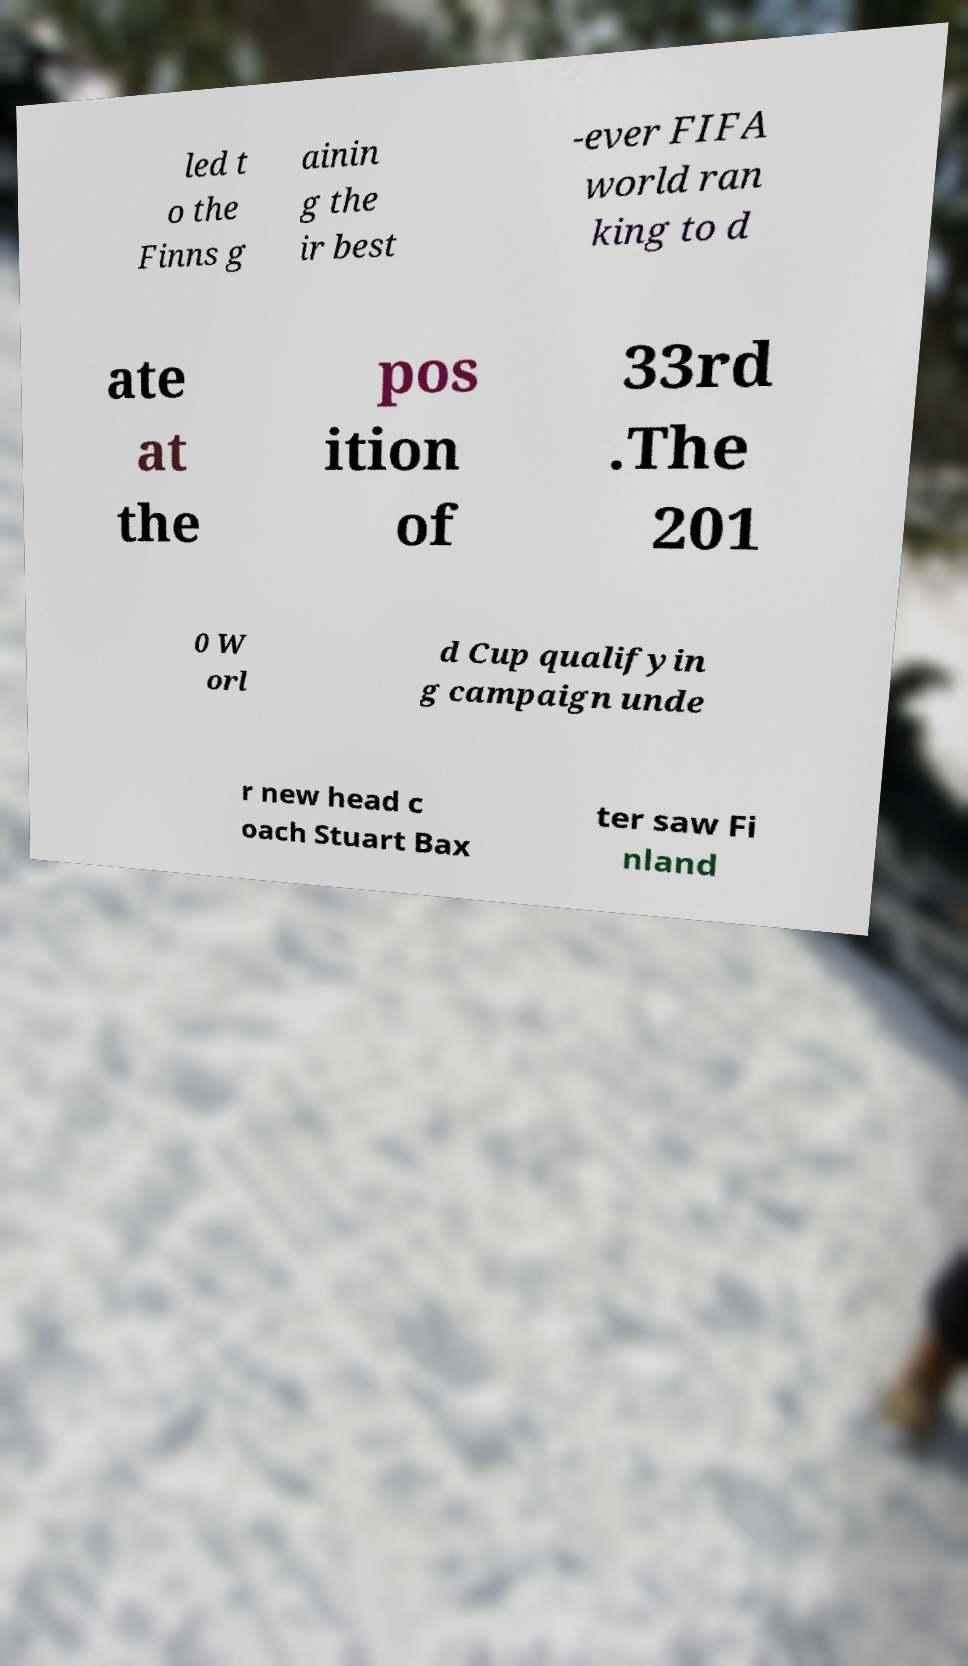Could you extract and type out the text from this image? led t o the Finns g ainin g the ir best -ever FIFA world ran king to d ate at the pos ition of 33rd .The 201 0 W orl d Cup qualifyin g campaign unde r new head c oach Stuart Bax ter saw Fi nland 